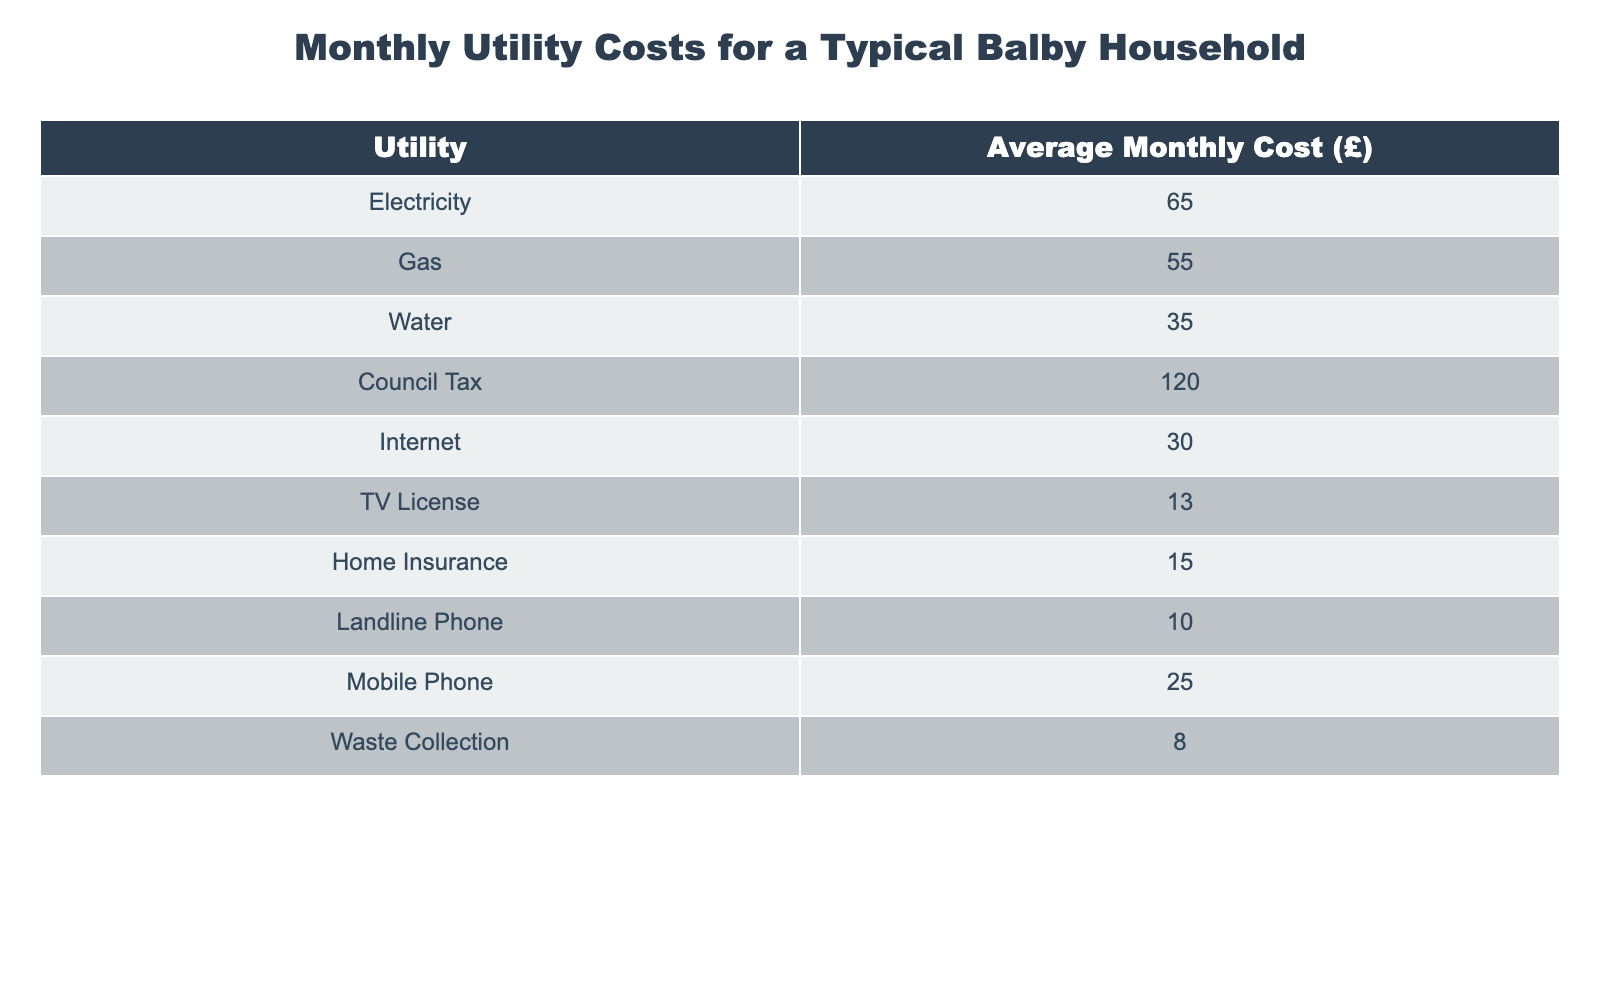What is the average monthly cost for electricity? The table shows that the average monthly cost for electricity is £65.
Answer: £65 What is the total monthly cost for gas and water? The average monthly cost for gas is £55 and for water is £35. Adding these together gives £55 + £35 = £90.
Answer: £90 Which utility has the highest monthly cost? Looking at the table, council tax has the highest monthly cost at £120.
Answer: £120 What is the combined cost of internet and mobile phone services? The cost for internet is £30 and for mobile phone is £25. Adding these two gives £30 + £25 = £55.
Answer: £55 Is the average monthly cost for home insurance more than that for a TV license? Home insurance costs £15 while a TV license costs £13. Since £15 is greater than £13, the statement is true.
Answer: Yes What is the average cost of all the utilities listed? First, we sum up all the costs: £65 + £55 + £35 + £120 + £30 + £13 + £15 + £10 + £25 + £8 = £413. There are 10 utilities, so the average is £413 / 10 = £41.30.
Answer: £41.30 Is the cost of waste collection higher or lower than that of a landline phone? The cost of waste collection is £8, and the cost of a landline phone is £10. Since £8 is less than £10, the answer is lower.
Answer: Lower What percentage of the total monthly utility cost does council tax represent? The total monthly utility cost is £413. Council tax costs £120. To find its percentage: (£120 / £413) * 100 ≈ 29.05%.
Answer: 29.05% If a household wants to reduce their utility costs by 10%, how much would that be in monetary terms? First, calculate 10% of the total utility cost, which is 10% of £413: £413 * 0.10 = £41.30.
Answer: £41.30 What would be the total monthly cost if a household only pays for electricity, gas, and council tax? The costs for electricity, gas, and council tax are £65, £55, and £120, respectively. Adding these, we find: £65 + £55 + £120 = £240.
Answer: £240 